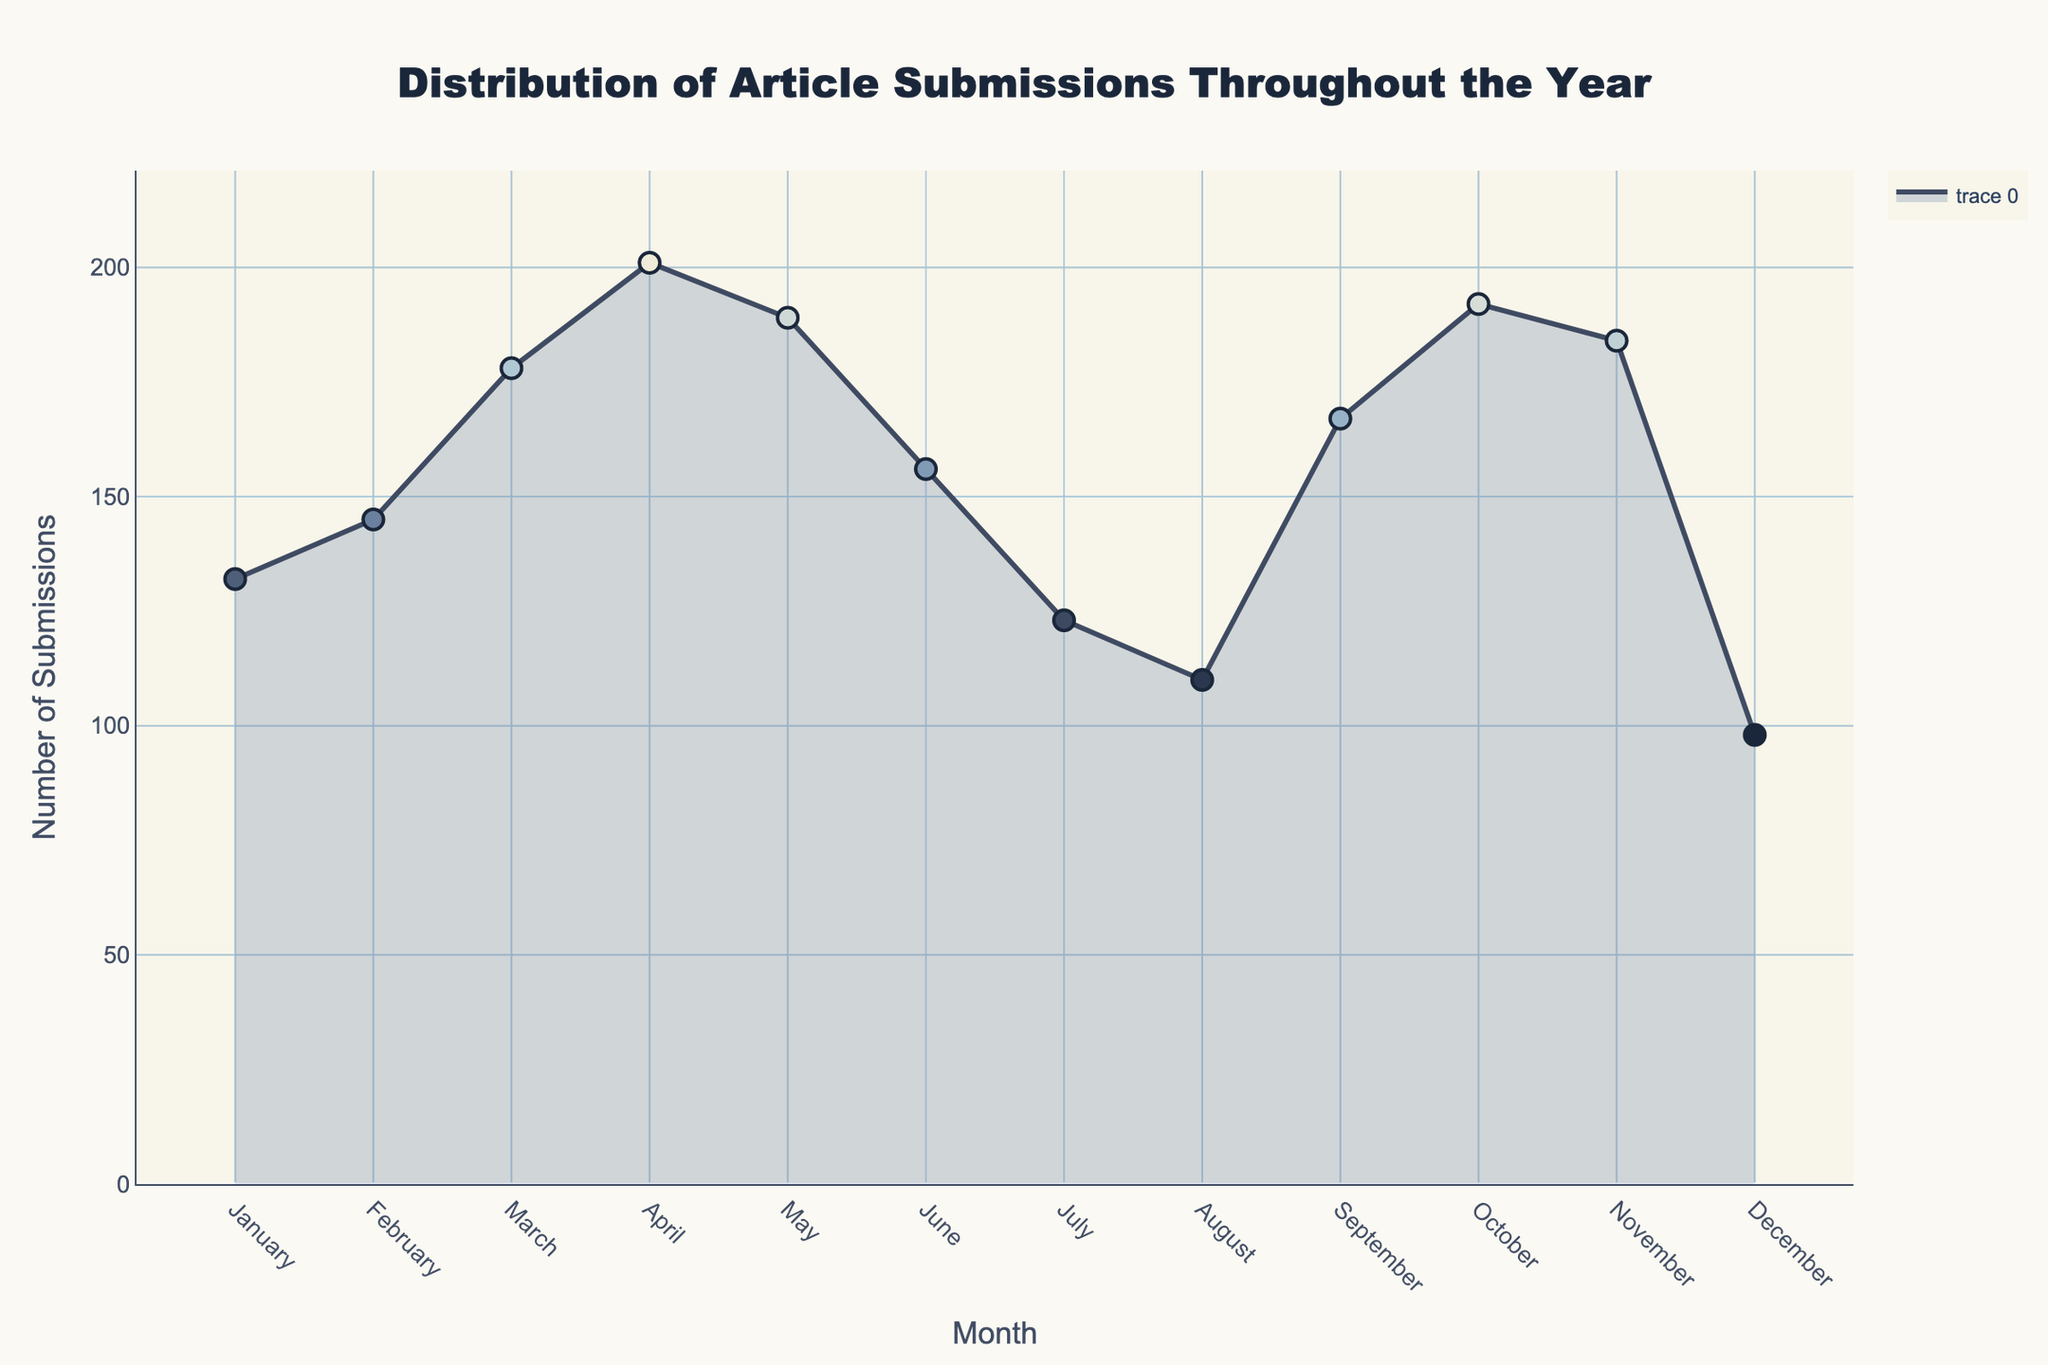What is the title of the figure? The title can be found at the top of the figure. It is "Distribution of Article Submissions Throughout the Year".
Answer: Distribution of Article Submissions Throughout the Year What is the highest number of submissions in any month? Identify the month with the peak in the density plot and note the corresponding value on the y-axis. The highest number of submissions is 201, which occurs in April.
Answer: 201 Which month has the lowest number of submissions? Look for the month with the lowest point in the plot. December has the lowest number of submissions with 98.
Answer: December What is the total number of submissions in the second quarter (April, May, and June)? Sum the submissions for April, May, and June: 201 (April) + 189 (May) + 156 (June) = 546.
Answer: 546 How do November's submissions compare to August's? Compare the y-values for November and August. November has 184 submissions, while August has 110. November has more submissions by 74.
Answer: November has 74 more submissions than August What is the average number of submissions per month? Add up the submissions for each month and divide by 12: (132 + 145 + 178 + 201 + 189 + 156 + 123 + 110 + 167 + 192 + 184 + 98) / 12 = 1675 / 12 ≈ 139.58.
Answer: ≈ 139.58 Is there any month with fewer than 100 submissions? Check the y-axis values for all months. December has fewer than 100 submissions with a total of 98.
Answer: Yes, December During which month do the submissions exceed 190? Identify months where the y-axis value is above 190. April and October both have submissions exceeding 190, with 201 and 192 respectively.
Answer: April and October Which quarter of the year (Q1, Q2, Q3, Q4) has the most submissions? Calculate the total submissions for each quarter and compare them. Q1: 132 + 145 + 178 = 455; Q2: 201 + 189 + 156 = 546; Q3: 123 + 110 + 167 = 400; Q4: 192 + 184 + 98 = 474. Q2 has the most submissions with 546.
Answer: Q2 